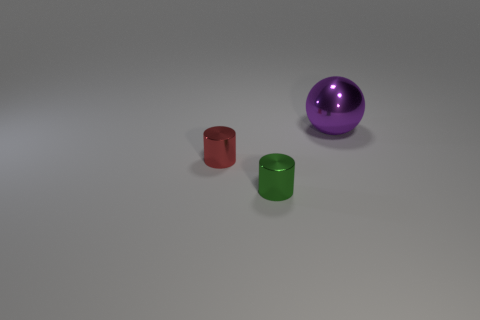Are there the same number of big spheres that are on the right side of the small green cylinder and large purple objects that are left of the large purple metal sphere?
Offer a terse response. No. Is there any other thing that is the same size as the purple thing?
Offer a terse response. No. The tiny thing that is the same material as the green cylinder is what color?
Keep it short and to the point. Red. Do the tiny red thing and the object behind the red metallic cylinder have the same material?
Your answer should be compact. Yes. There is a thing that is right of the small red cylinder and in front of the purple sphere; what color is it?
Your answer should be compact. Green. What number of cylinders are tiny red objects or metal objects?
Provide a short and direct response. 2. There is a red shiny object; is it the same shape as the shiny object that is in front of the red cylinder?
Your answer should be compact. Yes. What is the size of the metallic object that is behind the green metallic thing and right of the small red metal cylinder?
Your answer should be very brief. Large. There is a purple shiny thing; what shape is it?
Provide a succinct answer. Sphere. Are there any big metal spheres on the left side of the cylinder on the left side of the green shiny object?
Your answer should be very brief. No. 